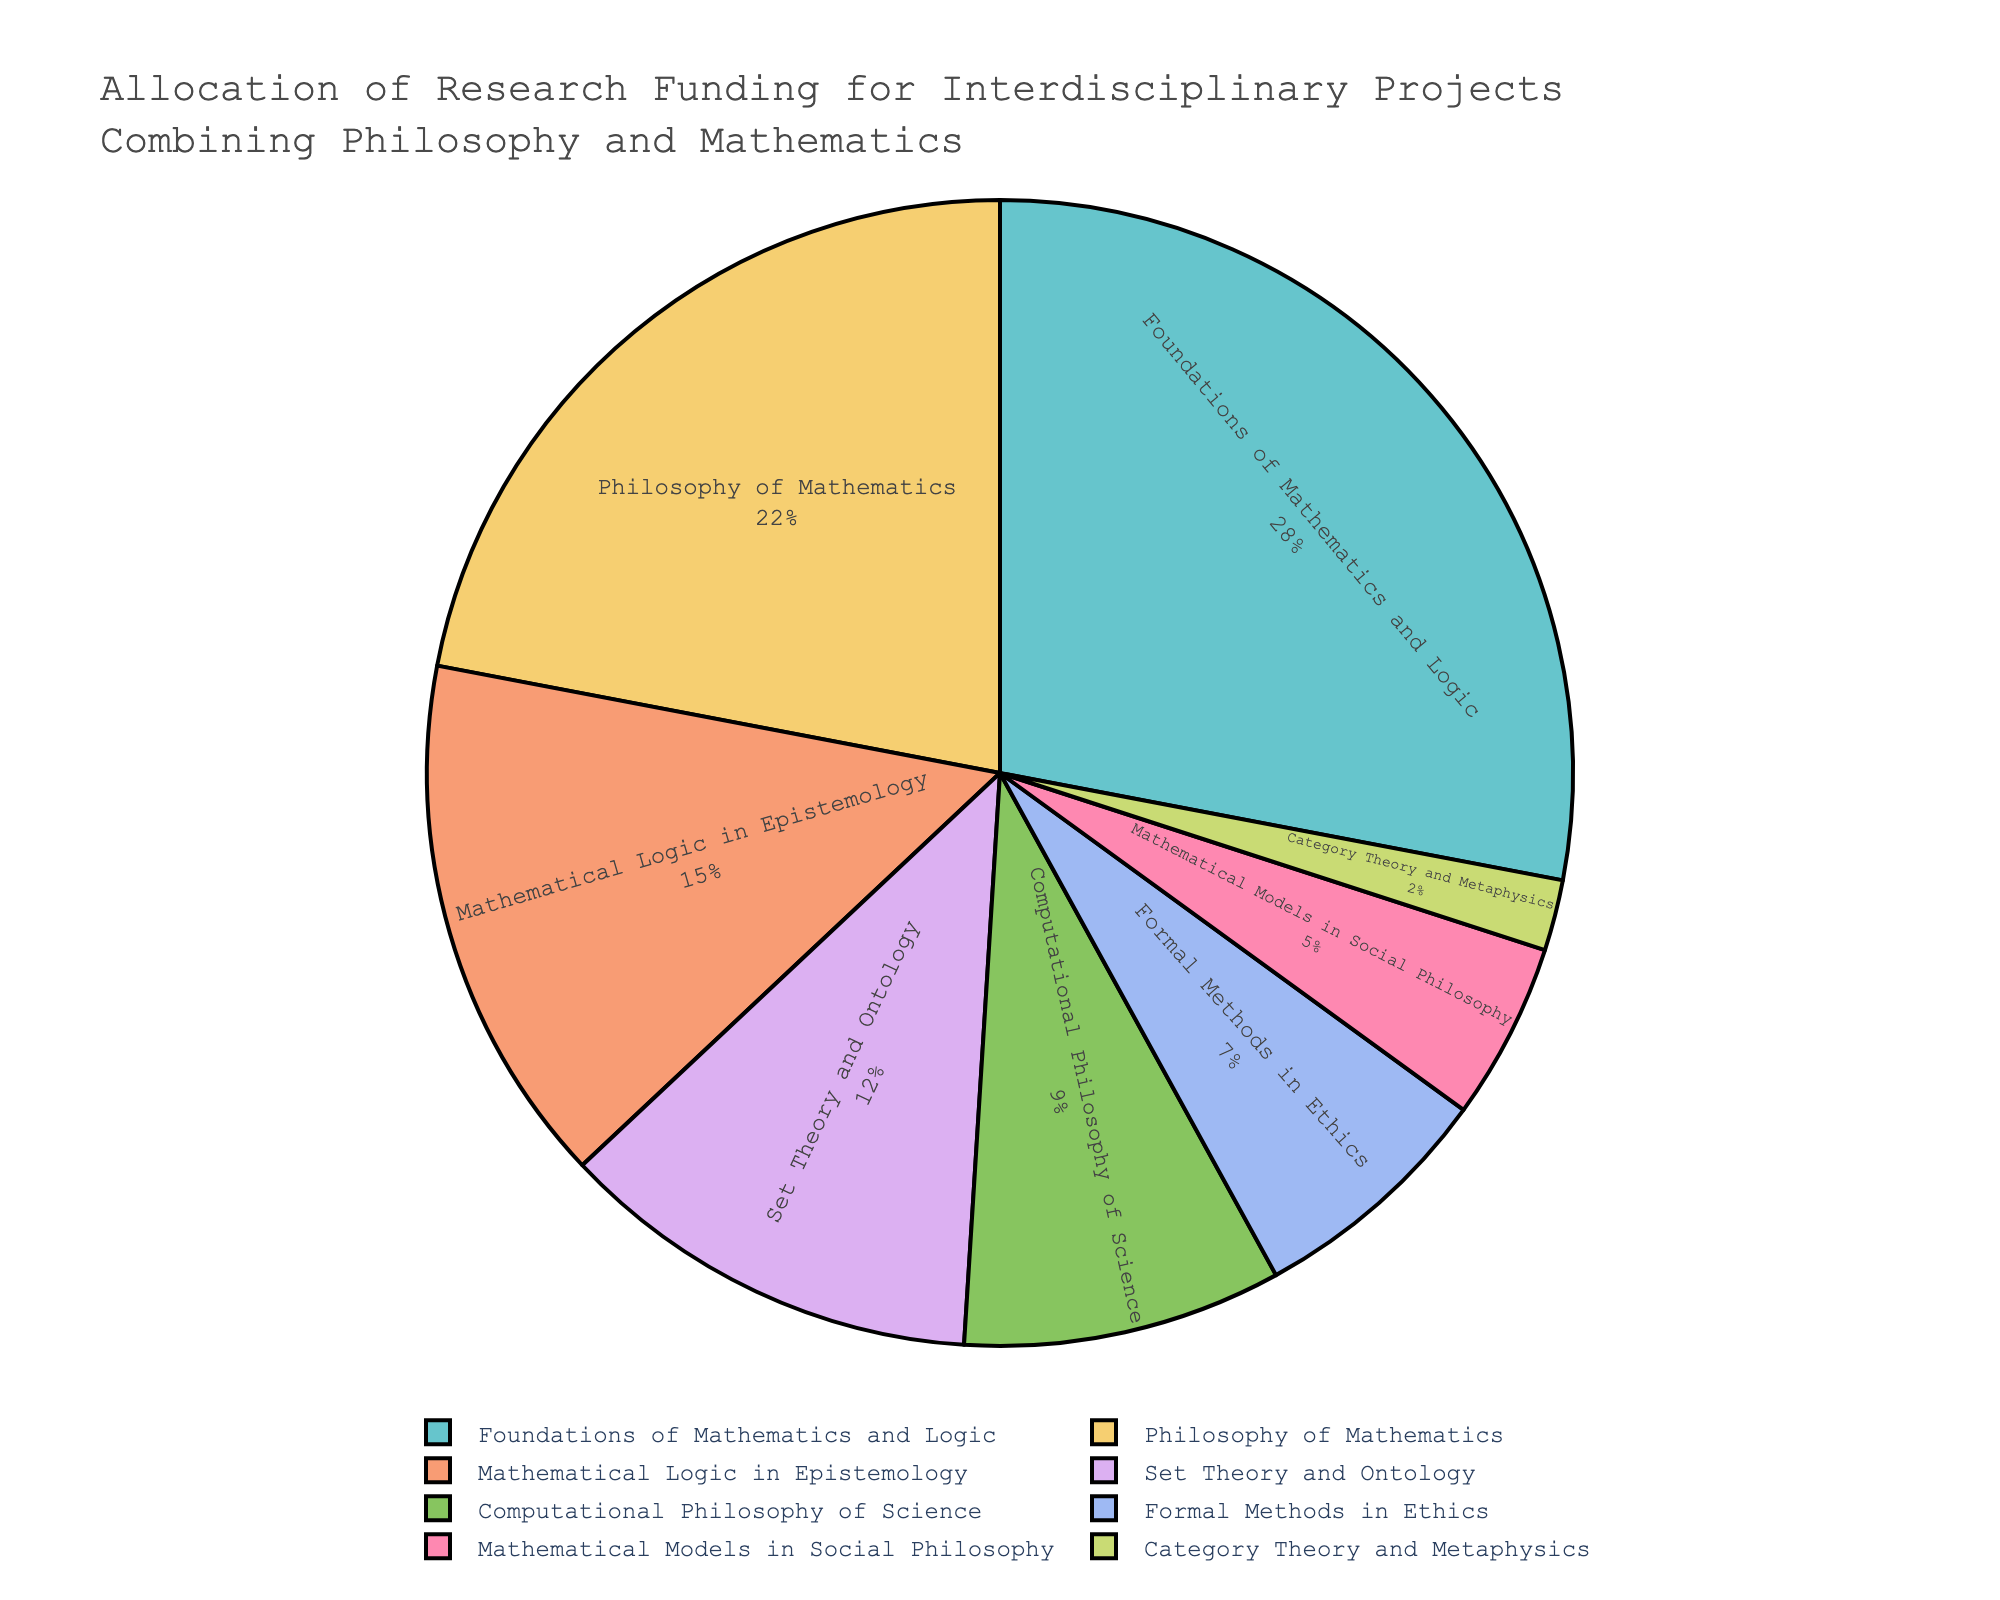Which category received the highest funding percentage? The category with the highest percentage is identified by the segment that takes up the largest area on the pie chart.
Answer: Foundations of Mathematics and Logic How much more funding percentage does the Foundations of Mathematics and Logic category receive compared to Mathematical Logic in Epistemology? Subtract the funding percentage of Mathematical Logic in Epistemology (15%) from that of Foundations of Mathematics and Logic (28%). 28% - 15% = 13%
Answer: 13% What is the combined funding percentage for Philosophy of Mathematics and Set Theory and Ontology? Add the funding percentages for Philosophy of Mathematics (22%) and Set Theory and Ontology (12%). 22% + 12% = 34%
Answer: 34% Which categories have a funding percentage less than 10%? Identify segments that cover less than 10% of the pie chart. Those categories are Computational Philosophy of Science (9%), Formal Methods in Ethics (7%), Mathematical Models in Social Philosophy (5%), and Category Theory and Metaphysics (2%).
Answer: Computational Philosophy of Science, Formal Methods in Ethics, Mathematical Models in Social Philosophy, Category Theory and Metaphysics How many categories have a greater funding percentage than Mathematical Logic in Epistemology? Count the number of segments with a higher percentage than Mathematical Logic in Epistemology (15%). Those categories are Foundations of Mathematics and Logic (28%) and Philosophy of Mathematics (22%).
Answer: 2 What is the total percentage allocated to categories that are related to logic? Add the funding percentages for Foundations of Mathematics and Logic (28%), Philosophy of Mathematics (22%), and Mathematical Logic in Epistemology (15%). 28% + 22% + 15% = 65%
Answer: 65% Which two categories, when combined, contribute the smallest and largest portions of funding? The smallest portions can be found by adding the two smallest percentages: Mathematical Models in Social Philosophy (5%) and Category Theory and Metaphysics (2%). The largest portions can be found by adding the two highest percentages: Foundations of Mathematics and Logic (28%) and Philosophy of Mathematics (22%).
Answer: Smallest: Mathematical Models in Social Philosophy and Category Theory and Metaphysics, Largest: Foundations of Mathematics and Logic and Philosophy of Mathematics What is the difference in funding percentage between the largest and smallest categories? Subtract the funding percentage of the smallest category (Category Theory and Metaphysics, 2%) from the funding percentage of the largest category (Foundations of Mathematics and Logic, 28%). 28% - 2% = 26%
Answer: 26% Which category represents the mid-range of funding allocations and what is its percentage? The mid-range category is the one positioned around the middle of the pie chart segments in terms of percentage. The middle category here is Mathematical Logic in Epistemology with 15%.
Answer: Mathematical Logic in Epistemology, 15% How does the funding for Formal Methods in Ethics compare to Computational Philosophy of Science? Determine if Formal Methods in Ethics (7%) is greater than, less than, or equal to Computational Philosophy of Science (9%). 7% is less than 9%.
Answer: Less than 